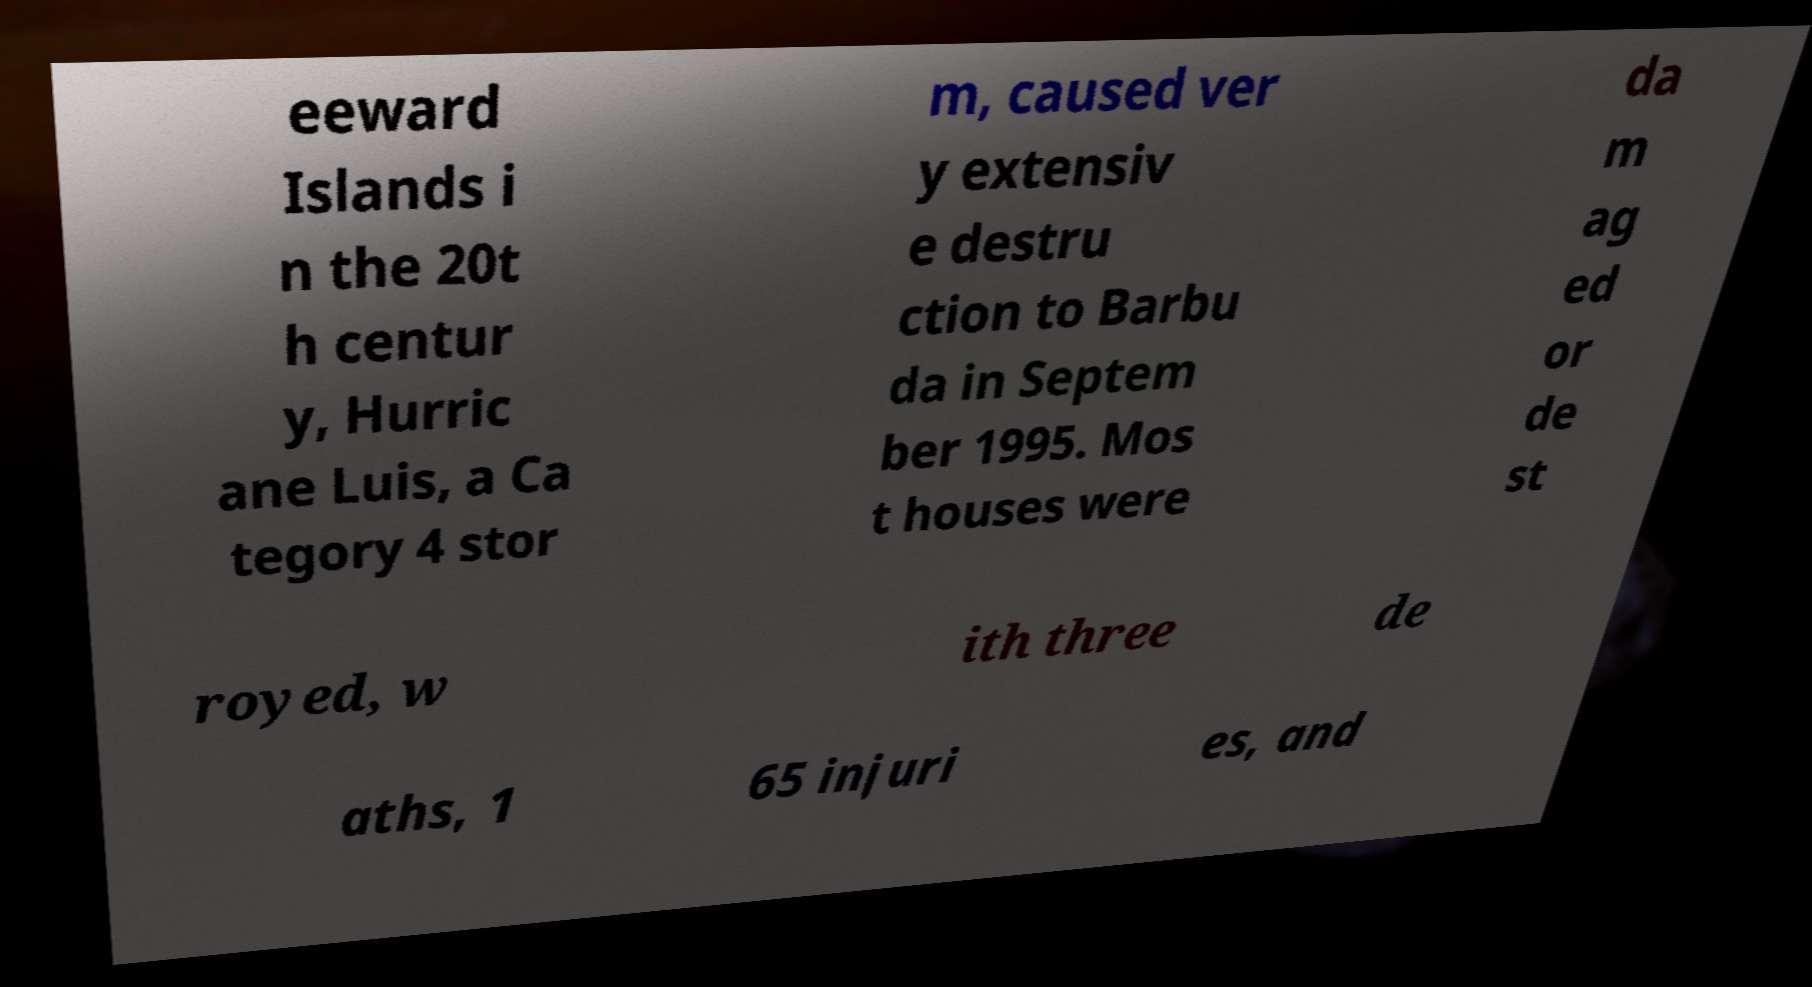Can you read and provide the text displayed in the image?This photo seems to have some interesting text. Can you extract and type it out for me? eeward Islands i n the 20t h centur y, Hurric ane Luis, a Ca tegory 4 stor m, caused ver y extensiv e destru ction to Barbu da in Septem ber 1995. Mos t houses were da m ag ed or de st royed, w ith three de aths, 1 65 injuri es, and 